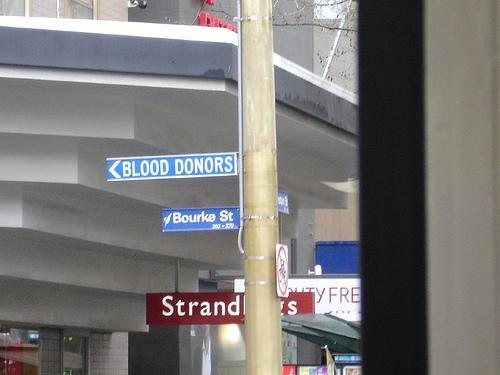What direction is the blood donors sign pointing?
Give a very brief answer. Left. What is the street name on the sign?
Keep it brief. Bourke. Are the first three letters of a word that means gratis shown here?
Be succinct. No. 